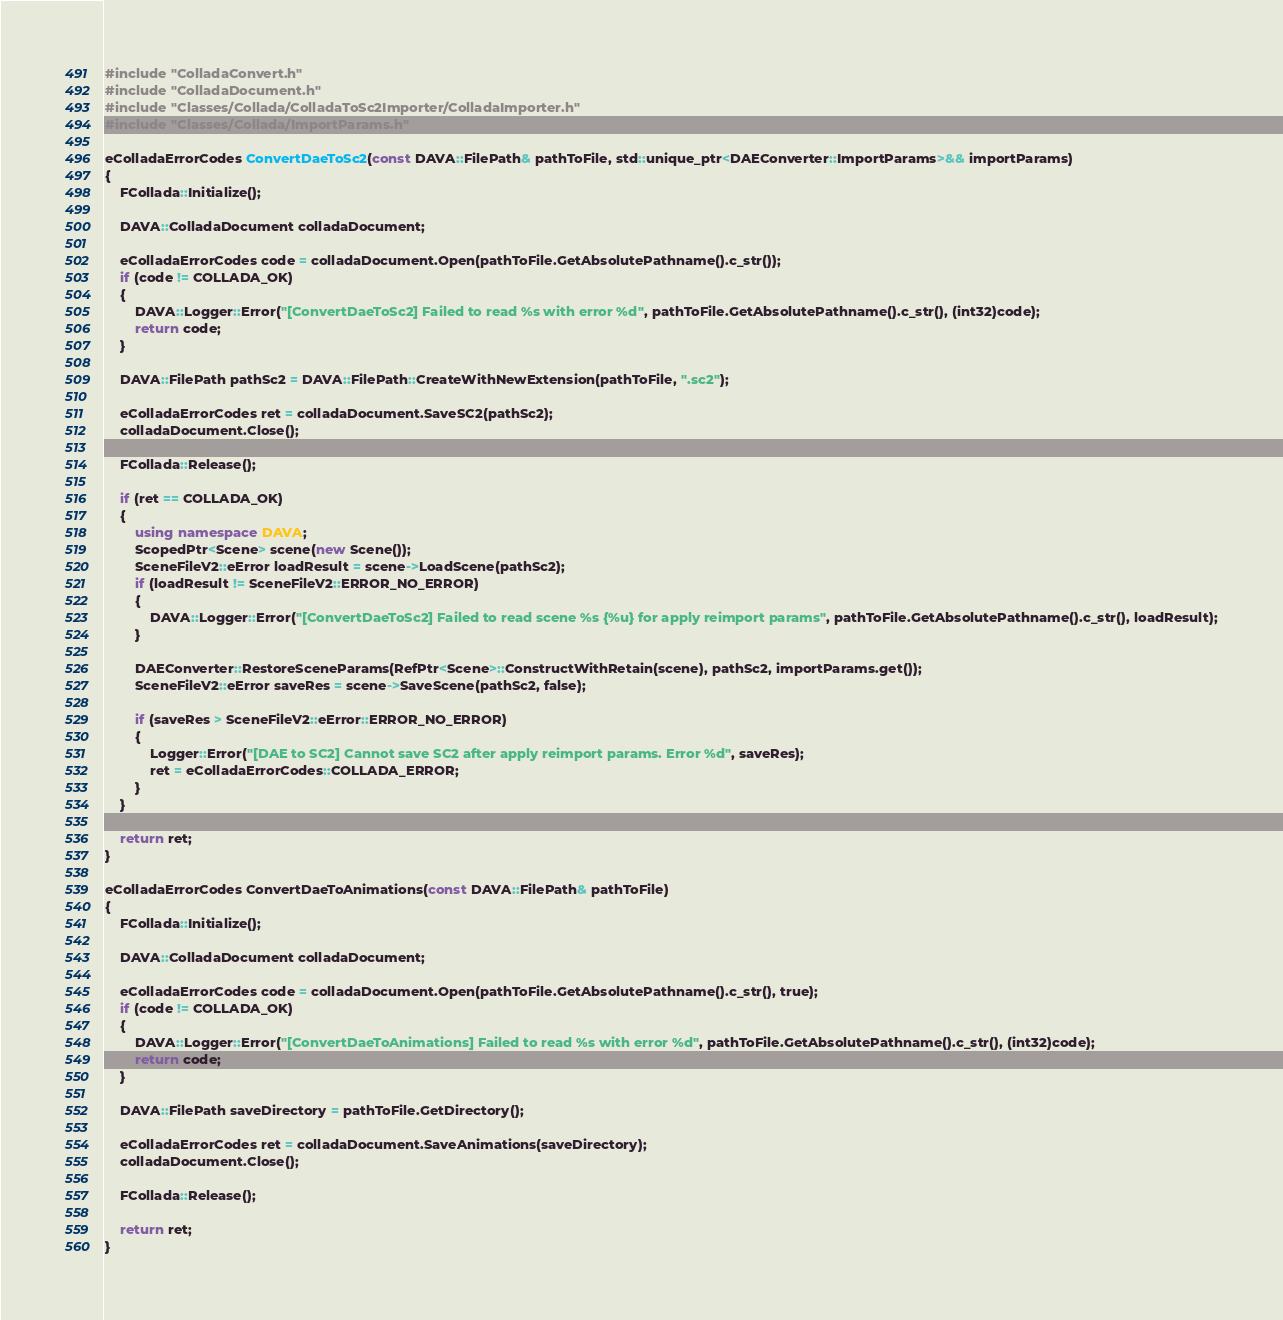Convert code to text. <code><loc_0><loc_0><loc_500><loc_500><_C++_>#include "ColladaConvert.h"
#include "ColladaDocument.h"
#include "Classes/Collada/ColladaToSc2Importer/ColladaImporter.h"
#include "Classes/Collada/ImportParams.h"

eColladaErrorCodes ConvertDaeToSc2(const DAVA::FilePath& pathToFile, std::unique_ptr<DAEConverter::ImportParams>&& importParams)
{
    FCollada::Initialize();

    DAVA::ColladaDocument colladaDocument;

    eColladaErrorCodes code = colladaDocument.Open(pathToFile.GetAbsolutePathname().c_str());
    if (code != COLLADA_OK)
    {
        DAVA::Logger::Error("[ConvertDaeToSc2] Failed to read %s with error %d", pathToFile.GetAbsolutePathname().c_str(), (int32)code);
        return code;
    }

    DAVA::FilePath pathSc2 = DAVA::FilePath::CreateWithNewExtension(pathToFile, ".sc2");

    eColladaErrorCodes ret = colladaDocument.SaveSC2(pathSc2);
    colladaDocument.Close();

    FCollada::Release();

    if (ret == COLLADA_OK)
    {
        using namespace DAVA;
        ScopedPtr<Scene> scene(new Scene());
        SceneFileV2::eError loadResult = scene->LoadScene(pathSc2);
        if (loadResult != SceneFileV2::ERROR_NO_ERROR)
        {
            DAVA::Logger::Error("[ConvertDaeToSc2] Failed to read scene %s {%u} for apply reimport params", pathToFile.GetAbsolutePathname().c_str(), loadResult);
        }

        DAEConverter::RestoreSceneParams(RefPtr<Scene>::ConstructWithRetain(scene), pathSc2, importParams.get());
        SceneFileV2::eError saveRes = scene->SaveScene(pathSc2, false);

        if (saveRes > SceneFileV2::eError::ERROR_NO_ERROR)
        {
            Logger::Error("[DAE to SC2] Cannot save SC2 after apply reimport params. Error %d", saveRes);
            ret = eColladaErrorCodes::COLLADA_ERROR;
        }
    }

    return ret;
}

eColladaErrorCodes ConvertDaeToAnimations(const DAVA::FilePath& pathToFile)
{
    FCollada::Initialize();

    DAVA::ColladaDocument colladaDocument;

    eColladaErrorCodes code = colladaDocument.Open(pathToFile.GetAbsolutePathname().c_str(), true);
    if (code != COLLADA_OK)
    {
        DAVA::Logger::Error("[ConvertDaeToAnimations] Failed to read %s with error %d", pathToFile.GetAbsolutePathname().c_str(), (int32)code);
        return code;
    }

    DAVA::FilePath saveDirectory = pathToFile.GetDirectory();

    eColladaErrorCodes ret = colladaDocument.SaveAnimations(saveDirectory);
    colladaDocument.Close();

    FCollada::Release();

    return ret;
}
</code> 